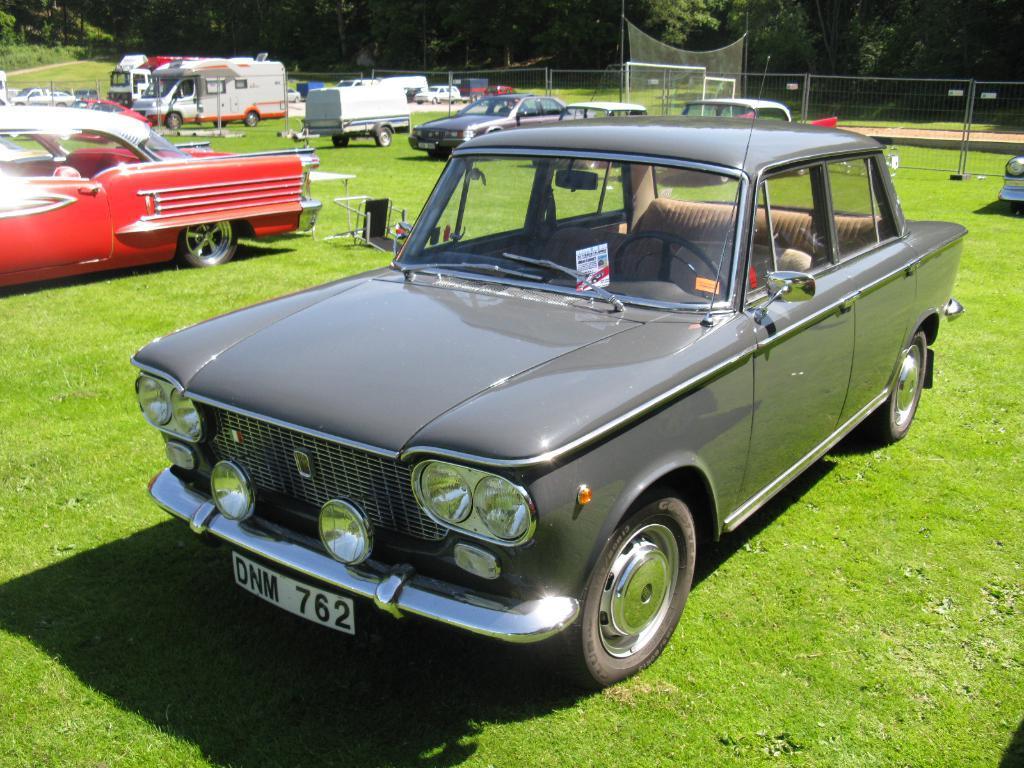In one or two sentences, can you explain what this image depicts? In this picture we can see some vehicles on the grass path and on the path there are some objects. Behind the vehicles there is a fence, net and trees. 